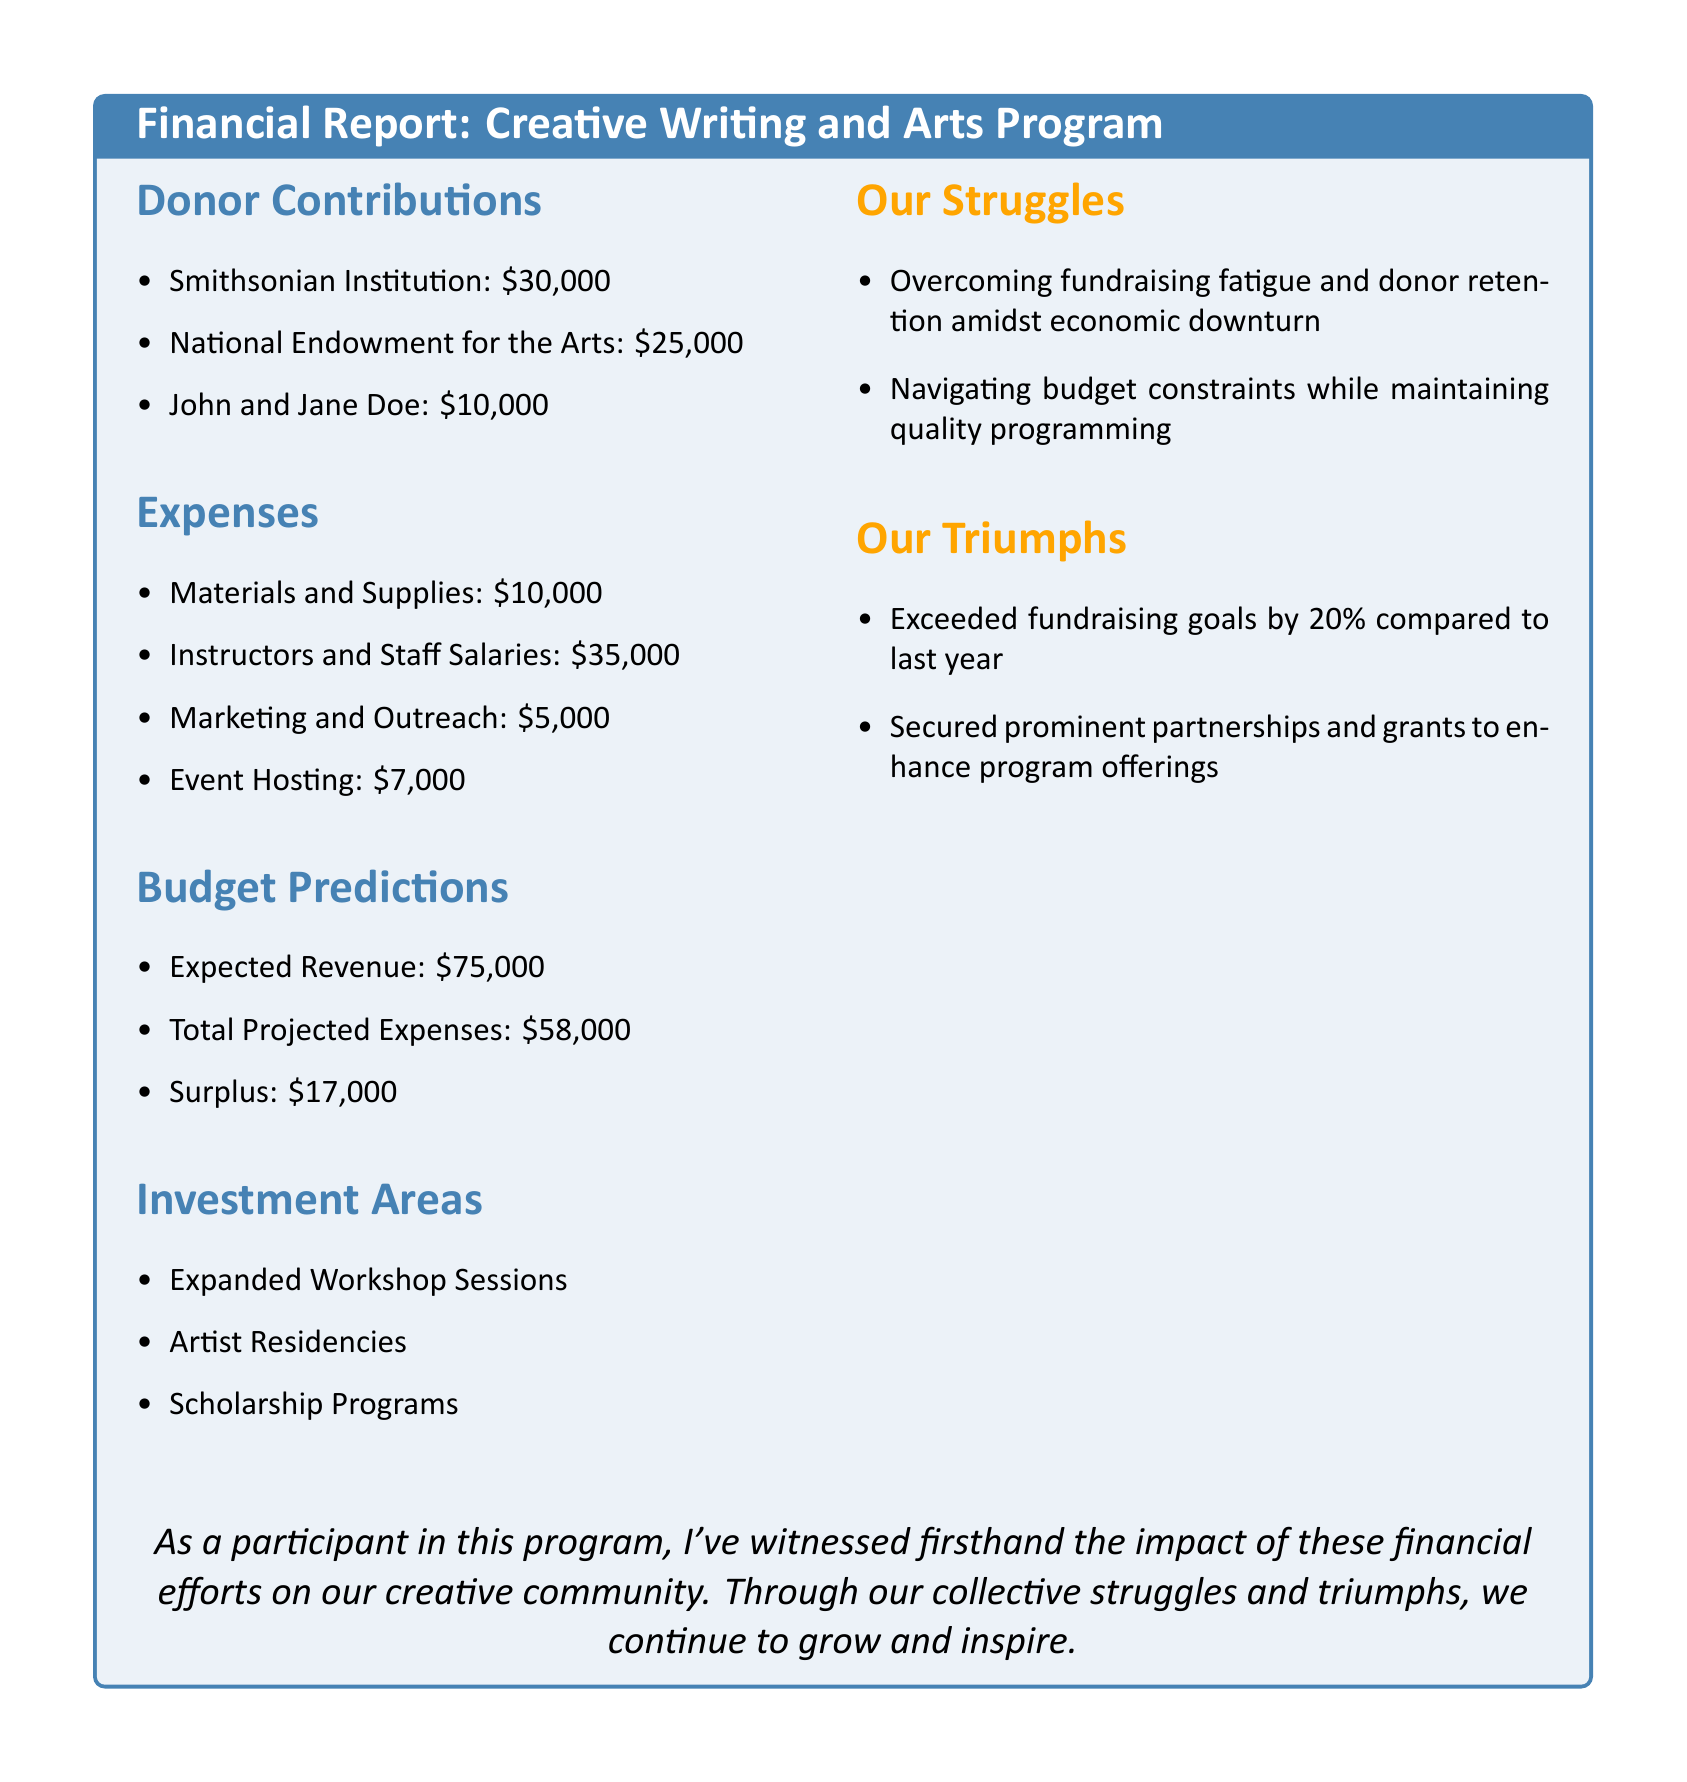What are the total donor contributions? The total donor contributions can be calculated by adding all listed contributions: $30,000 + $25,000 + $10,000 = $65,000.
Answer: $65,000 What is the amount spent on instructor and staff salaries? The document specifies the expenses, and the amount allocated for instructors and staff salaries is clearly stated.
Answer: $35,000 What is the expected revenue for the program? The expected revenue is listed directly in the budget predictions section of the document.
Answer: $75,000 Which organization contributed the highest amount? The highest donor contribution is clearly listed in the document, making it easy to identify.
Answer: Smithsonian Institution What is the total projected expenses? Total projected expenses are summarized in the budget predictions section and can be found directly there.
Answer: $58,000 What percentage did fundraising goals exceed by compared to last year? The document mentions a specific percentage related to fundraising goals, making it easy to find the answer.
Answer: 20% What are some investment areas mentioned? The document lists specific areas that will receive investment, which can be easily referenced.
Answer: Expanded Workshop Sessions, Artist Residencies, Scholarship Programs What struggle is mentioned about fundraising? One of the specific struggles related to fundraising is stated in the document, giving insight into challenges faced.
Answer: Fundraising fatigue What triumph was secured to enhance program offerings? The document highlights specific achievements, which can be directly referenced for an answer.
Answer: Partnerships and grants 